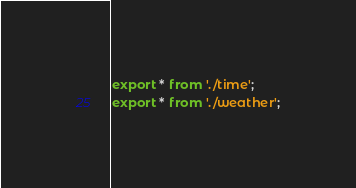<code> <loc_0><loc_0><loc_500><loc_500><_TypeScript_>export * from './time';
export * from './weather';
</code> 